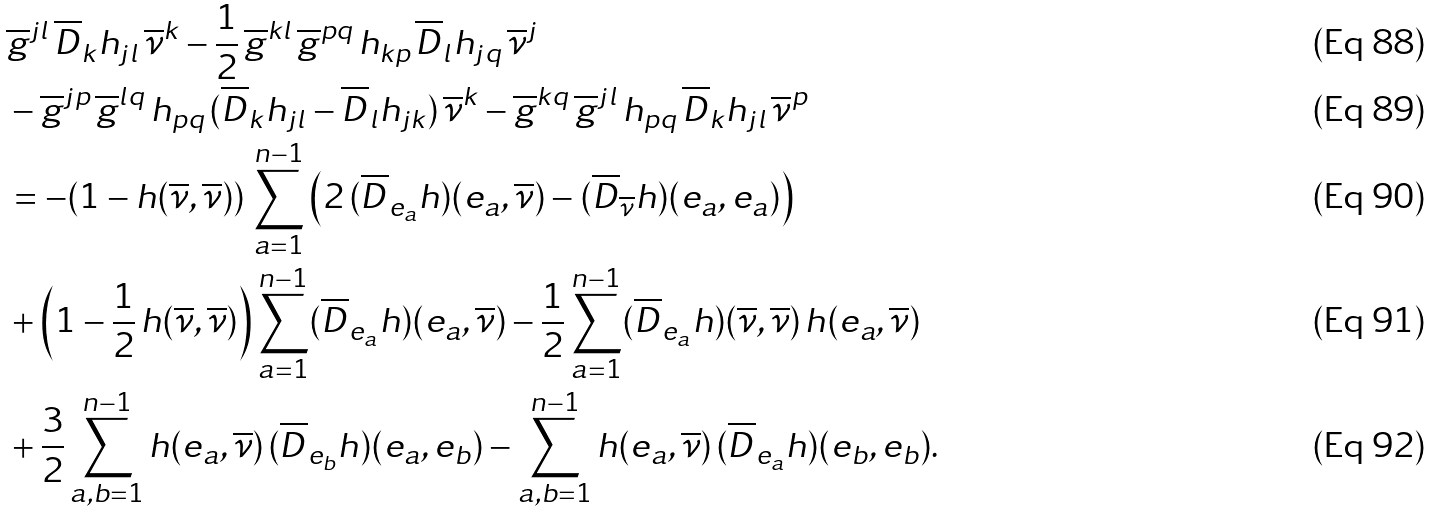<formula> <loc_0><loc_0><loc_500><loc_500>& \overline { g } ^ { j l } \, \overline { D } _ { k } h _ { j l } \, \overline { \nu } ^ { k } - \frac { 1 } { 2 } \, \overline { g } ^ { k l } \, \overline { g } ^ { p q } \, h _ { k p } \, \overline { D } _ { l } h _ { j q } \, \overline { \nu } ^ { j } \\ & - \overline { g } ^ { j p } \, \overline { g } ^ { l q } \, h _ { p q } \, ( \overline { D } _ { k } h _ { j l } - \overline { D } _ { l } h _ { j k } ) \, \overline { \nu } ^ { k } - \overline { g } ^ { k q } \, \overline { g } ^ { j l } \, h _ { p q } \, \overline { D } _ { k } h _ { j l } \, \overline { \nu } ^ { p } \\ & = - ( 1 - h ( \overline { \nu } , \overline { \nu } ) ) \, \sum _ { a = 1 } ^ { n - 1 } \left ( 2 \, ( \overline { D } _ { e _ { a } } h ) ( e _ { a } , \overline { \nu } ) - ( \overline { D } _ { \overline { \nu } } h ) ( e _ { a } , e _ { a } ) \right ) \\ & + \left ( 1 - \frac { 1 } { 2 } \, h ( \overline { \nu } , \overline { \nu } ) \right ) \sum _ { a = 1 } ^ { n - 1 } ( \overline { D } _ { e _ { a } } h ) ( e _ { a } , \overline { \nu } ) - \frac { 1 } { 2 } \sum _ { a = 1 } ^ { n - 1 } ( \overline { D } _ { e _ { a } } h ) ( \overline { \nu } , \overline { \nu } ) \, h ( e _ { a } , \overline { \nu } ) \\ & + \frac { 3 } { 2 } \sum _ { a , b = 1 } ^ { n - 1 } h ( e _ { a } , \overline { \nu } ) \, ( \overline { D } _ { e _ { b } } h ) ( e _ { a } , e _ { b } ) - \sum _ { a , b = 1 } ^ { n - 1 } h ( e _ { a } , \overline { \nu } ) \, ( \overline { D } _ { e _ { a } } h ) ( e _ { b } , e _ { b } ) .</formula> 